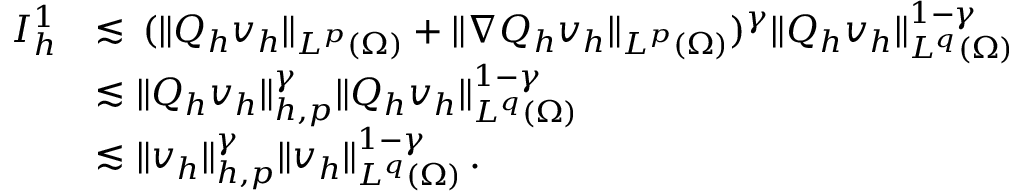<formula> <loc_0><loc_0><loc_500><loc_500>\begin{array} { r } { \begin{array} { r l } { I _ { h } ^ { 1 } } & { \lesssim \, ( \| Q _ { h } v _ { h } \| _ { L ^ { p } ( \Omega ) } + \| \nabla Q _ { h } v _ { h } \| _ { L ^ { p } ( \Omega ) } ) ^ { \gamma } \| Q _ { h } v _ { h } \| _ { L ^ { q } ( \Omega ) } ^ { 1 - \gamma } } \\ & { \lesssim \| Q _ { h } v _ { h } \| _ { h , p } ^ { \gamma } \| Q _ { h } v _ { h } \| _ { L ^ { q } ( \Omega ) } ^ { 1 - \gamma } } \\ & { \lesssim \| v _ { h } \| _ { h , p } ^ { \gamma } \| v _ { h } \| _ { L ^ { q } ( \Omega ) } ^ { 1 - \gamma } \, . } \end{array} } \end{array}</formula> 